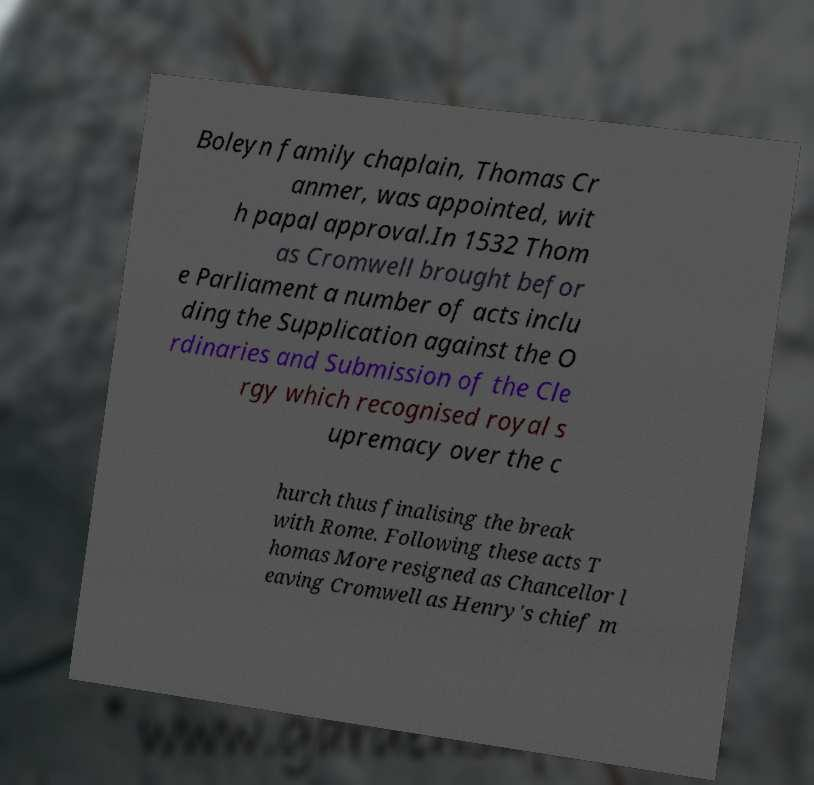There's text embedded in this image that I need extracted. Can you transcribe it verbatim? Boleyn family chaplain, Thomas Cr anmer, was appointed, wit h papal approval.In 1532 Thom as Cromwell brought befor e Parliament a number of acts inclu ding the Supplication against the O rdinaries and Submission of the Cle rgy which recognised royal s upremacy over the c hurch thus finalising the break with Rome. Following these acts T homas More resigned as Chancellor l eaving Cromwell as Henry's chief m 